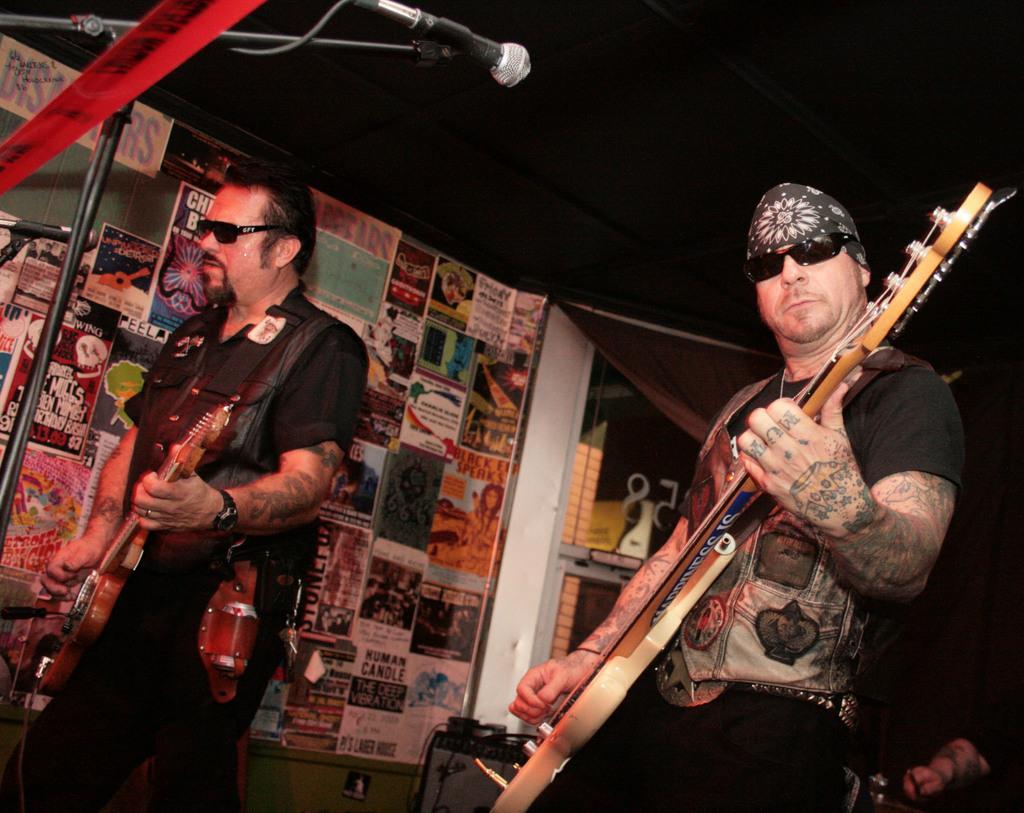In one or two sentences, can you explain what this image depicts? This image is clicked inside under the tent. There are two person performing music. To the right, there is a man playing guitar. At the top, there is a stand alone with mic and there is also a tent. In the background, there is a wall on which posters are kept. 